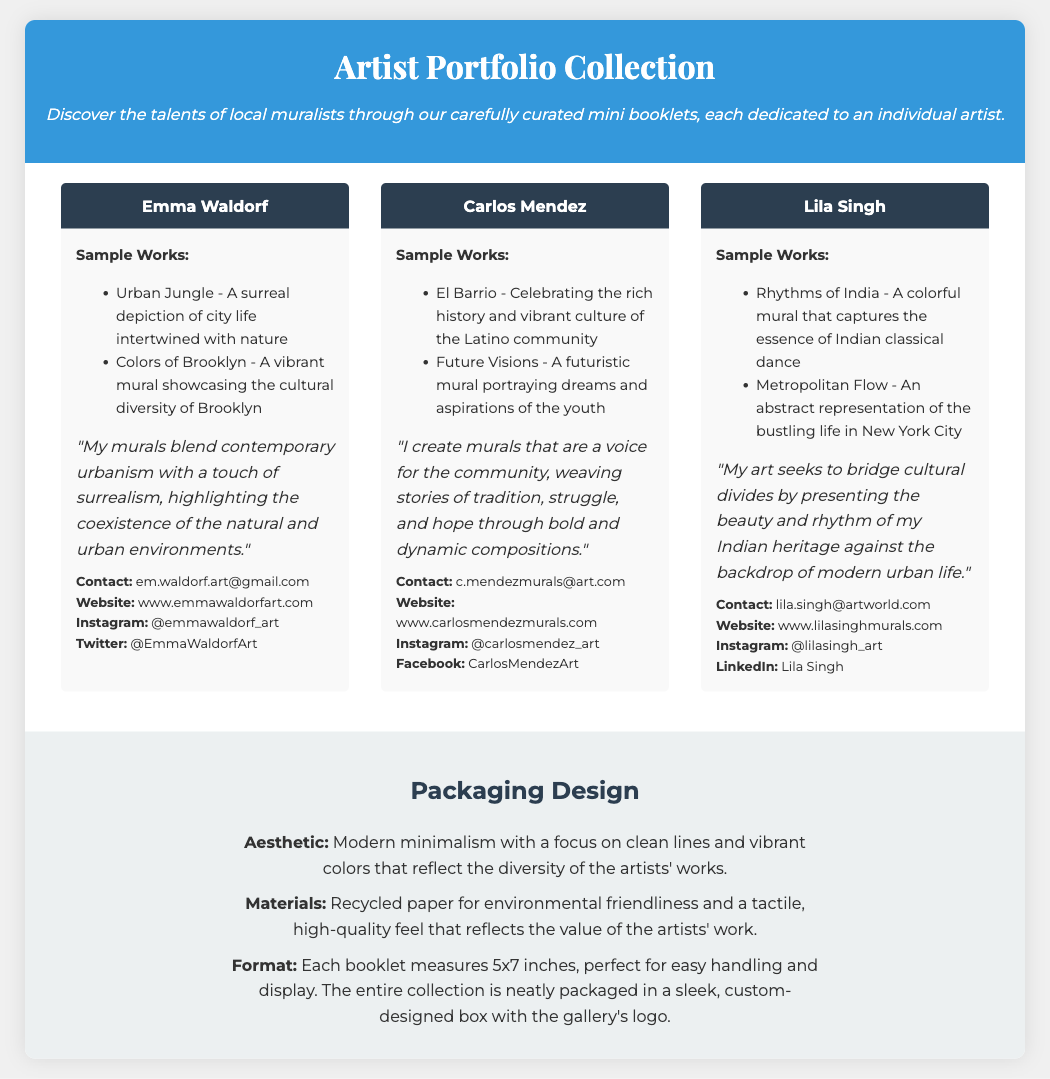What is the title of the document? The title of the document is provided in the header section, which describes the content of the collection.
Answer: Artist Portfolio Collection Who is the artist featured in the first card? The first artist's name is displayed prominently at the top of the card.
Answer: Emma Waldorf How many sample works are listed for Carlos Mendez? The number of sample works for Carlos Mendez can be found by counting the items in the list provided on his artist card.
Answer: 2 What is Lila Singh's contact email? The email address for Lila Singh is provided in the contact section of her artist card.
Answer: lila.singh@artworld.com What aesthetic is used in the packaging design? The document describes the aesthetic in the packaging section, detailing its style and visual impact.
Answer: Modern minimalism What format do the individual booklets measure? The measurement of each booklet is specified in the packaging section, detailing its physical dimensions for easy handling.
Answer: 5x7 inches How many artists are included in this portfolio collection? The total number of artist cards presented in the collection indicates the number of artists showcased.
Answer: 3 What materials are used for the packaging? The type of materials used for the packaging is stated in the packaging section to highlight its eco-friendliness.
Answer: Recycled paper What does Carlos Mendez aim to express through his murals? The artist's statement provides insight into his artistic goals and themes expressed in his work.
Answer: A voice for the community 